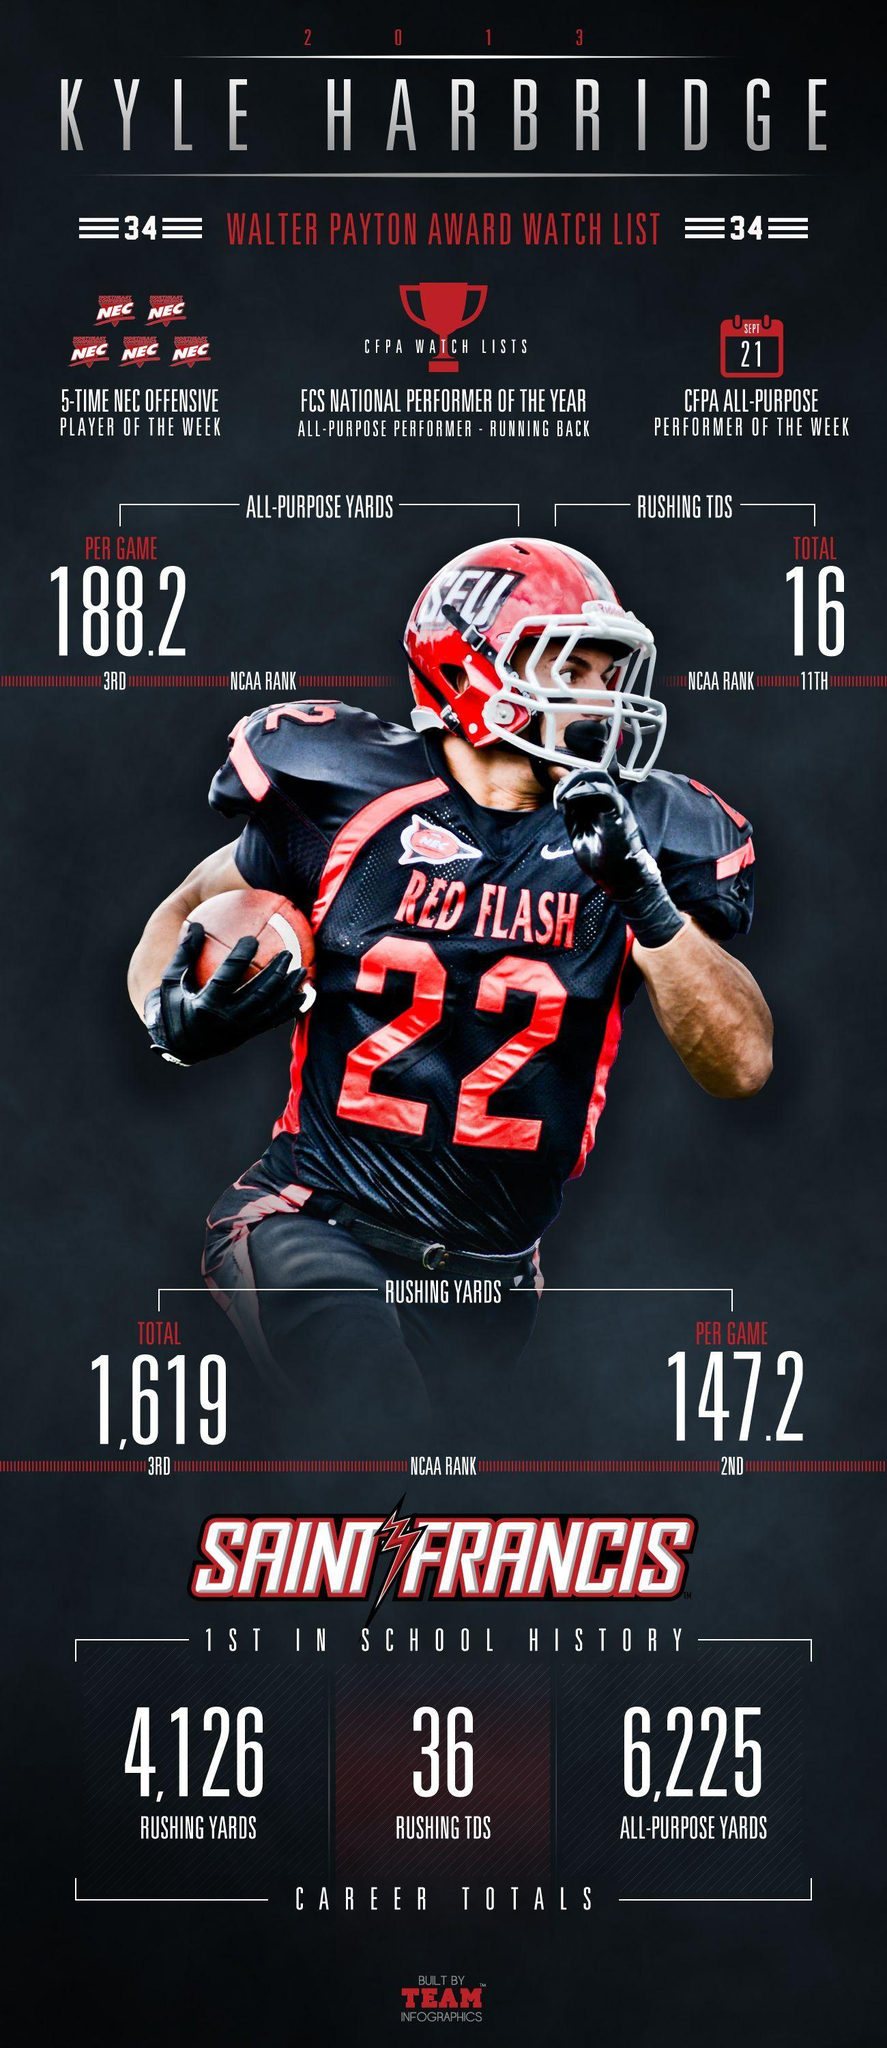What is the All-purpose yards per game for Kyle Harbridge?
Answer the question with a short phrase. 188.2 What is the Rushing yards per game for Kyle Harbridge? 147.2 What is the Total Rushing TDS for Kyle Harbridge? 16 What is the Total Rushing yards for Kyle Harbridge? 1,619 